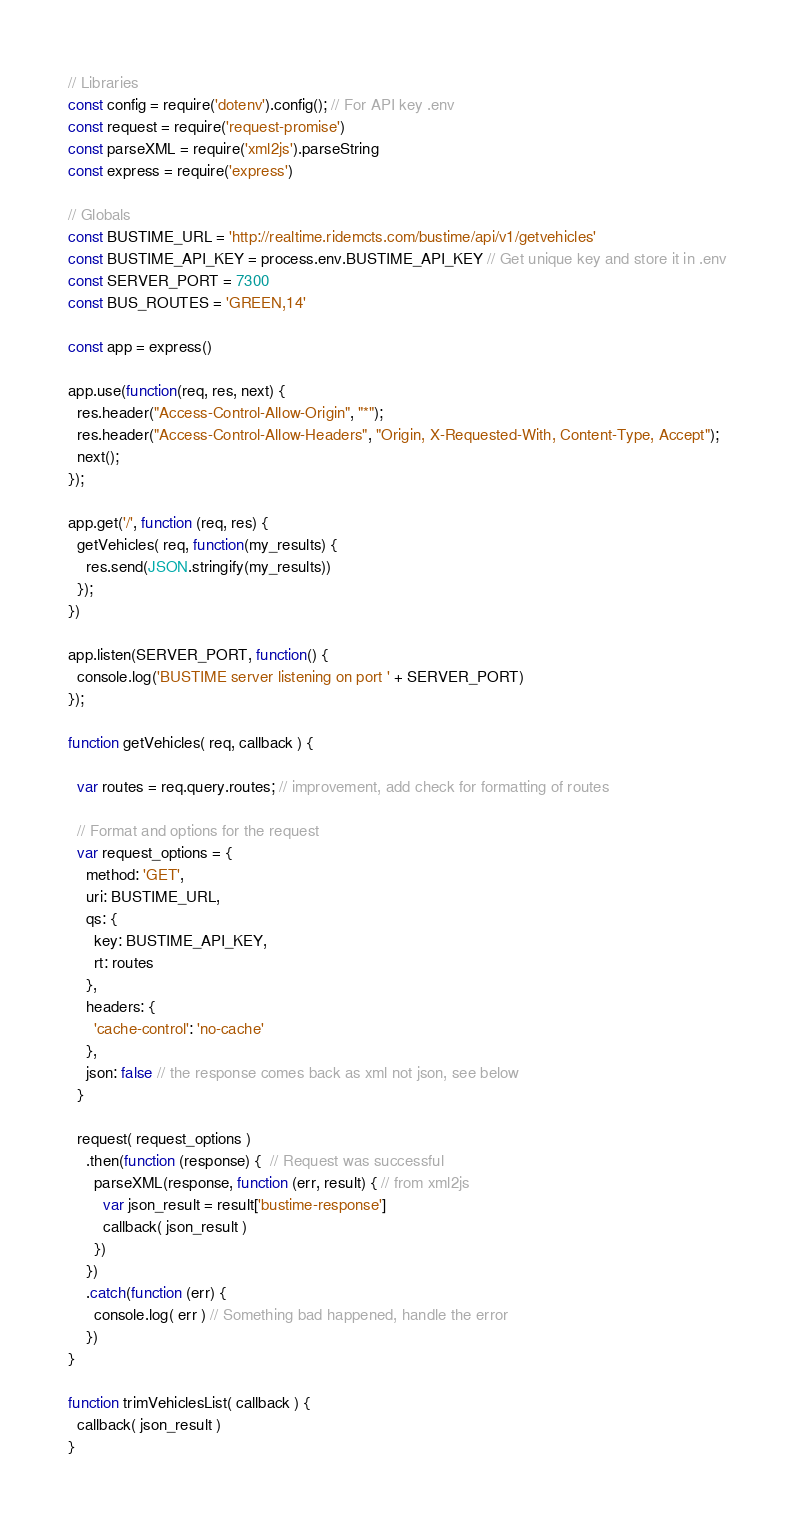Convert code to text. <code><loc_0><loc_0><loc_500><loc_500><_JavaScript_>// Libraries
const config = require('dotenv').config(); // For API key .env
const request = require('request-promise')
const parseXML = require('xml2js').parseString
const express = require('express')

// Globals
const BUSTIME_URL = 'http://realtime.ridemcts.com/bustime/api/v1/getvehicles'
const BUSTIME_API_KEY = process.env.BUSTIME_API_KEY // Get unique key and store it in .env
const SERVER_PORT = 7300
const BUS_ROUTES = 'GREEN,14'

const app = express()

app.use(function(req, res, next) {
  res.header("Access-Control-Allow-Origin", "*");
  res.header("Access-Control-Allow-Headers", "Origin, X-Requested-With, Content-Type, Accept");
  next();
});

app.get('/', function (req, res) {
  getVehicles( req, function(my_results) {
    res.send(JSON.stringify(my_results))
  });
})

app.listen(SERVER_PORT, function() {
  console.log('BUSTIME server listening on port ' + SERVER_PORT)
});

function getVehicles( req, callback ) {

  var routes = req.query.routes; // improvement, add check for formatting of routes

  // Format and options for the request
  var request_options = {
    method: 'GET',
    uri: BUSTIME_URL,
    qs: {
      key: BUSTIME_API_KEY,
      rt: routes
    },
    headers: {
      'cache-control': 'no-cache'
    },
    json: false // the response comes back as xml not json, see below
  }

  request( request_options )
    .then(function (response) {  // Request was successful
      parseXML(response, function (err, result) { // from xml2js
        var json_result = result['bustime-response']
        callback( json_result )
      })
    })
    .catch(function (err) {
      console.log( err ) // Something bad happened, handle the error
    })
}

function trimVehiclesList( callback ) {
  callback( json_result )
}
</code> 